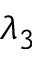Convert formula to latex. <formula><loc_0><loc_0><loc_500><loc_500>\lambda _ { 3 }</formula> 